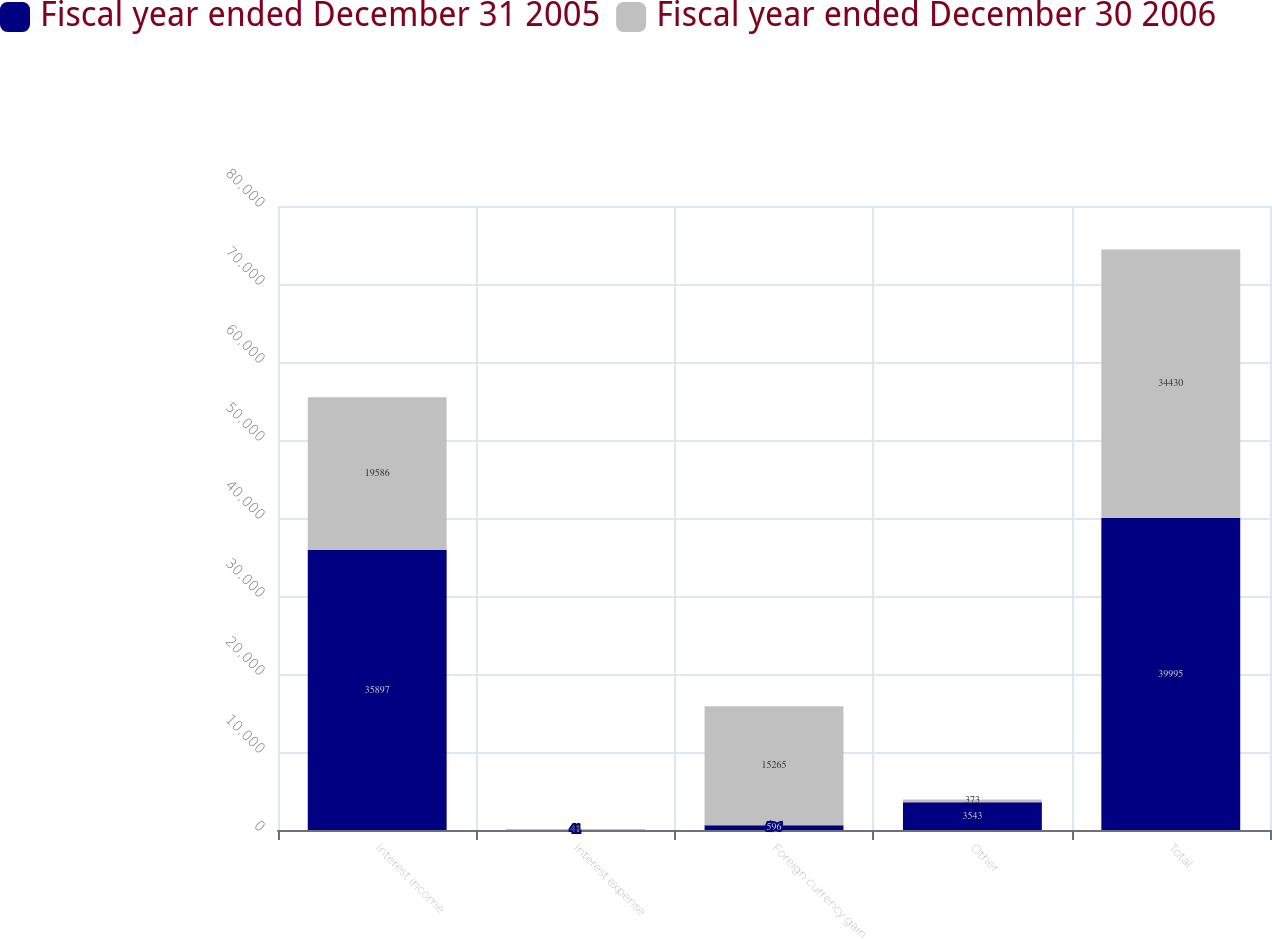Convert chart to OTSL. <chart><loc_0><loc_0><loc_500><loc_500><stacked_bar_chart><ecel><fcel>Interest income<fcel>Interest expense<fcel>Foreign currency gain<fcel>Other<fcel>Total<nl><fcel>Fiscal year ended December 31 2005<fcel>35897<fcel>41<fcel>596<fcel>3543<fcel>39995<nl><fcel>Fiscal year ended December 30 2006<fcel>19586<fcel>48<fcel>15265<fcel>373<fcel>34430<nl></chart> 